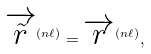Convert formula to latex. <formula><loc_0><loc_0><loc_500><loc_500>\overrightarrow { \tilde { r } } ^ { ( n \ell ) } = \overrightarrow { r } ^ { ( n \ell ) } ,</formula> 